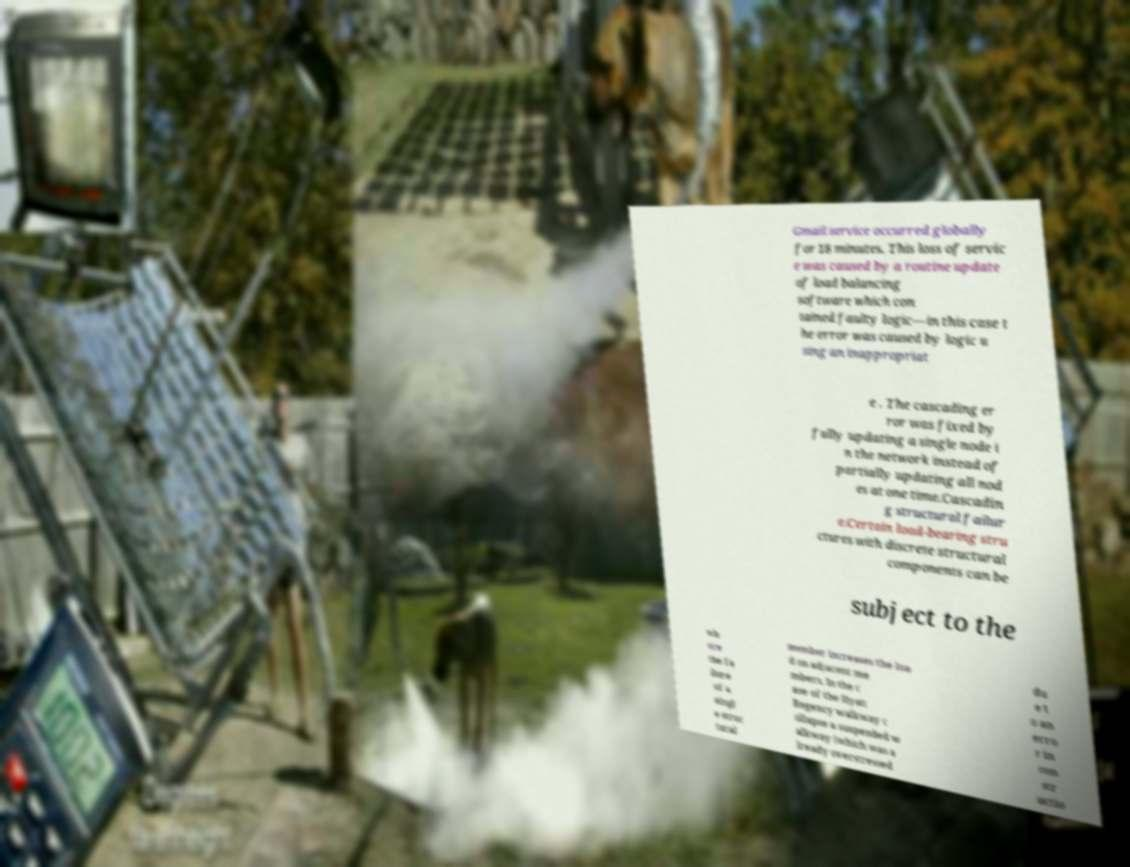Could you extract and type out the text from this image? Gmail service occurred globally for 18 minutes. This loss of servic e was caused by a routine update of load balancing software which con tained faulty logic—in this case t he error was caused by logic u sing an inappropriat e . The cascading er ror was fixed by fully updating a single node i n the network instead of partially updating all nod es at one time.Cascadin g structural failur e.Certain load-bearing stru ctures with discrete structural components can be subject to the wh ere the fa ilure of a singl e struc tural member increases the loa d on adjacent me mbers. In the c ase of the Hyatt Regency walkway c ollapse a suspended w alkway (which was a lready overstressed du e t o an erro r in con str uctio 